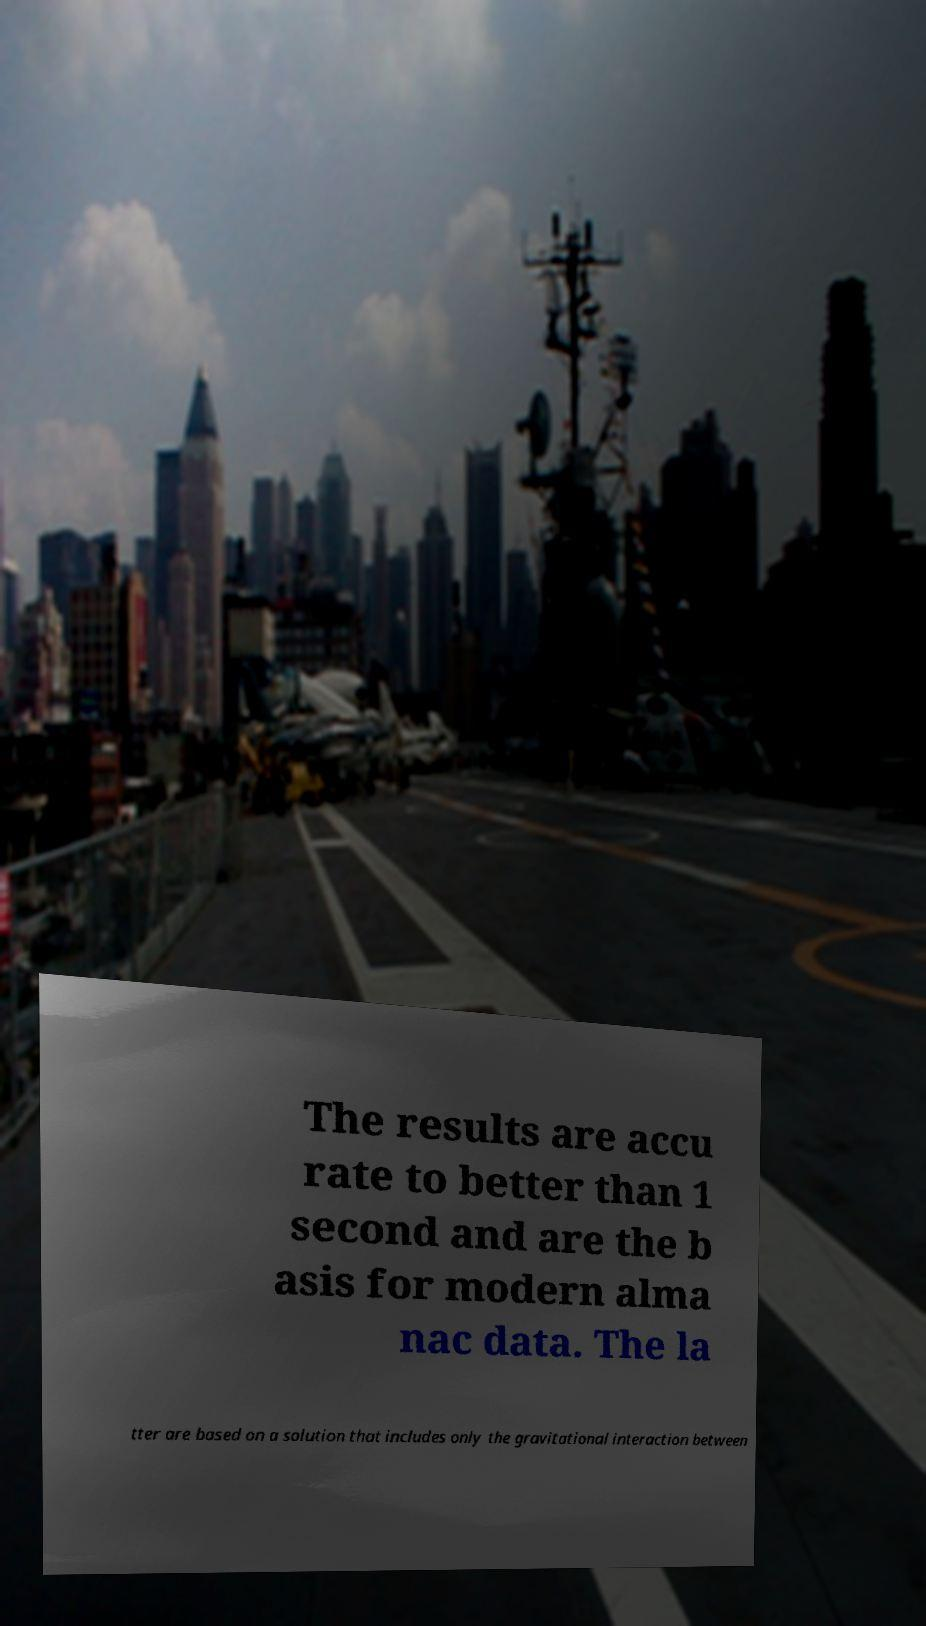Please read and relay the text visible in this image. What does it say? The results are accu rate to better than 1 second and are the b asis for modern alma nac data. The la tter are based on a solution that includes only the gravitational interaction between 